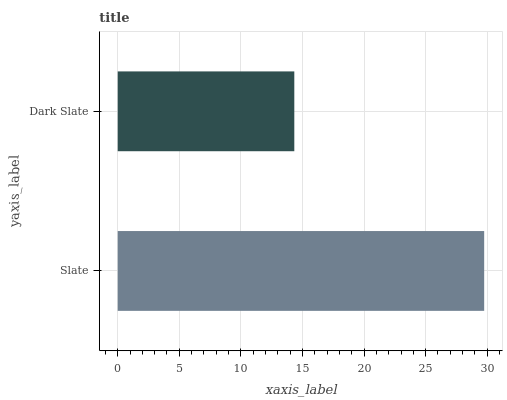Is Dark Slate the minimum?
Answer yes or no. Yes. Is Slate the maximum?
Answer yes or no. Yes. Is Dark Slate the maximum?
Answer yes or no. No. Is Slate greater than Dark Slate?
Answer yes or no. Yes. Is Dark Slate less than Slate?
Answer yes or no. Yes. Is Dark Slate greater than Slate?
Answer yes or no. No. Is Slate less than Dark Slate?
Answer yes or no. No. Is Slate the high median?
Answer yes or no. Yes. Is Dark Slate the low median?
Answer yes or no. Yes. Is Dark Slate the high median?
Answer yes or no. No. Is Slate the low median?
Answer yes or no. No. 